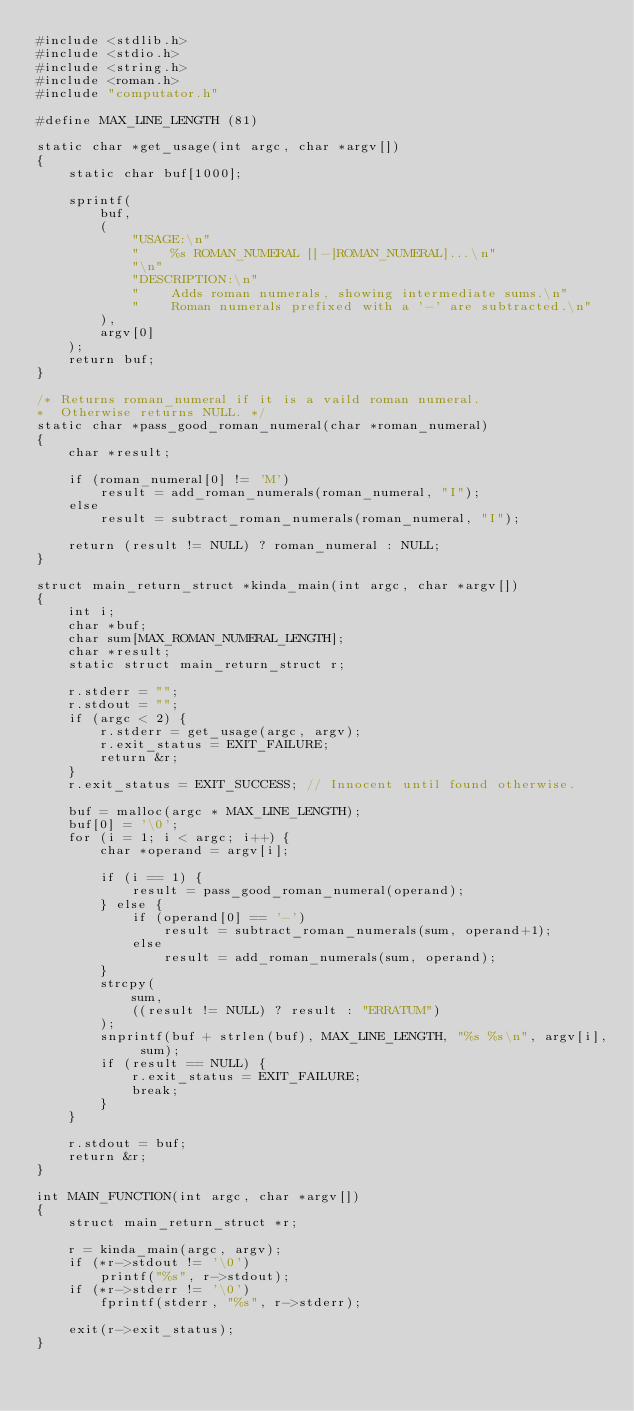Convert code to text. <code><loc_0><loc_0><loc_500><loc_500><_C_>#include <stdlib.h>
#include <stdio.h>
#include <string.h>
#include <roman.h>
#include "computator.h"

#define MAX_LINE_LENGTH (81)

static char *get_usage(int argc, char *argv[])
{
    static char buf[1000];

    sprintf(
        buf,
        (
            "USAGE:\n"
            "    %s ROMAN_NUMERAL [[-]ROMAN_NUMERAL]...\n"
            "\n"
            "DESCRIPTION:\n"
            "    Adds roman numerals, showing intermediate sums.\n"
            "    Roman numerals prefixed with a '-' are subtracted.\n"
        ),
        argv[0]
    );
    return buf;
}

/* Returns roman_numeral if it is a vaild roman numeral.
*  Otherwise returns NULL. */
static char *pass_good_roman_numeral(char *roman_numeral)
{
    char *result;

    if (roman_numeral[0] != 'M')
        result = add_roman_numerals(roman_numeral, "I");
    else
        result = subtract_roman_numerals(roman_numeral, "I");

    return (result != NULL) ? roman_numeral : NULL;
}

struct main_return_struct *kinda_main(int argc, char *argv[])
{
    int i;
    char *buf;
    char sum[MAX_ROMAN_NUMERAL_LENGTH];
    char *result;
    static struct main_return_struct r;

    r.stderr = "";
    r.stdout = "";
    if (argc < 2) {
        r.stderr = get_usage(argc, argv);
        r.exit_status = EXIT_FAILURE;
        return &r;
    }
    r.exit_status = EXIT_SUCCESS; // Innocent until found otherwise.

    buf = malloc(argc * MAX_LINE_LENGTH);
    buf[0] = '\0';
    for (i = 1; i < argc; i++) {
        char *operand = argv[i];

        if (i == 1) {
            result = pass_good_roman_numeral(operand);
        } else {
            if (operand[0] == '-')
                result = subtract_roman_numerals(sum, operand+1);
            else
                result = add_roman_numerals(sum, operand);
        }
        strcpy(
            sum,
            ((result != NULL) ? result : "ERRATUM")
        );
        snprintf(buf + strlen(buf), MAX_LINE_LENGTH, "%s %s\n", argv[i], sum);
        if (result == NULL) {
            r.exit_status = EXIT_FAILURE;
            break;
        }
    }

    r.stdout = buf;
    return &r;
}

int MAIN_FUNCTION(int argc, char *argv[])
{
    struct main_return_struct *r;

    r = kinda_main(argc, argv);
    if (*r->stdout != '\0')
        printf("%s", r->stdout);
    if (*r->stderr != '\0')
        fprintf(stderr, "%s", r->stderr);

    exit(r->exit_status);
}
</code> 